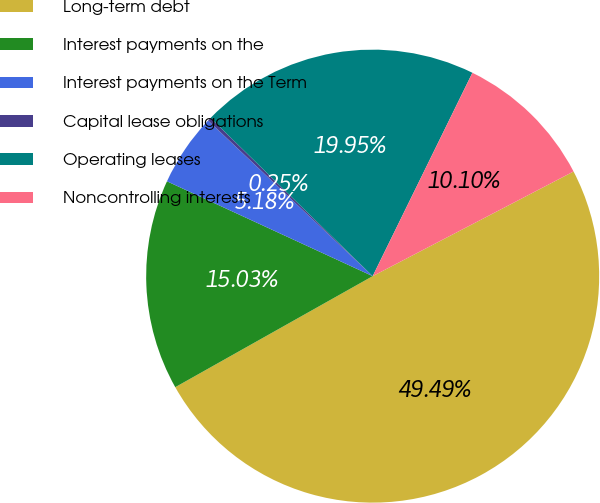Convert chart. <chart><loc_0><loc_0><loc_500><loc_500><pie_chart><fcel>Long-term debt<fcel>Interest payments on the<fcel>Interest payments on the Term<fcel>Capital lease obligations<fcel>Operating leases<fcel>Noncontrolling interests<nl><fcel>49.49%<fcel>15.03%<fcel>5.18%<fcel>0.25%<fcel>19.95%<fcel>10.1%<nl></chart> 